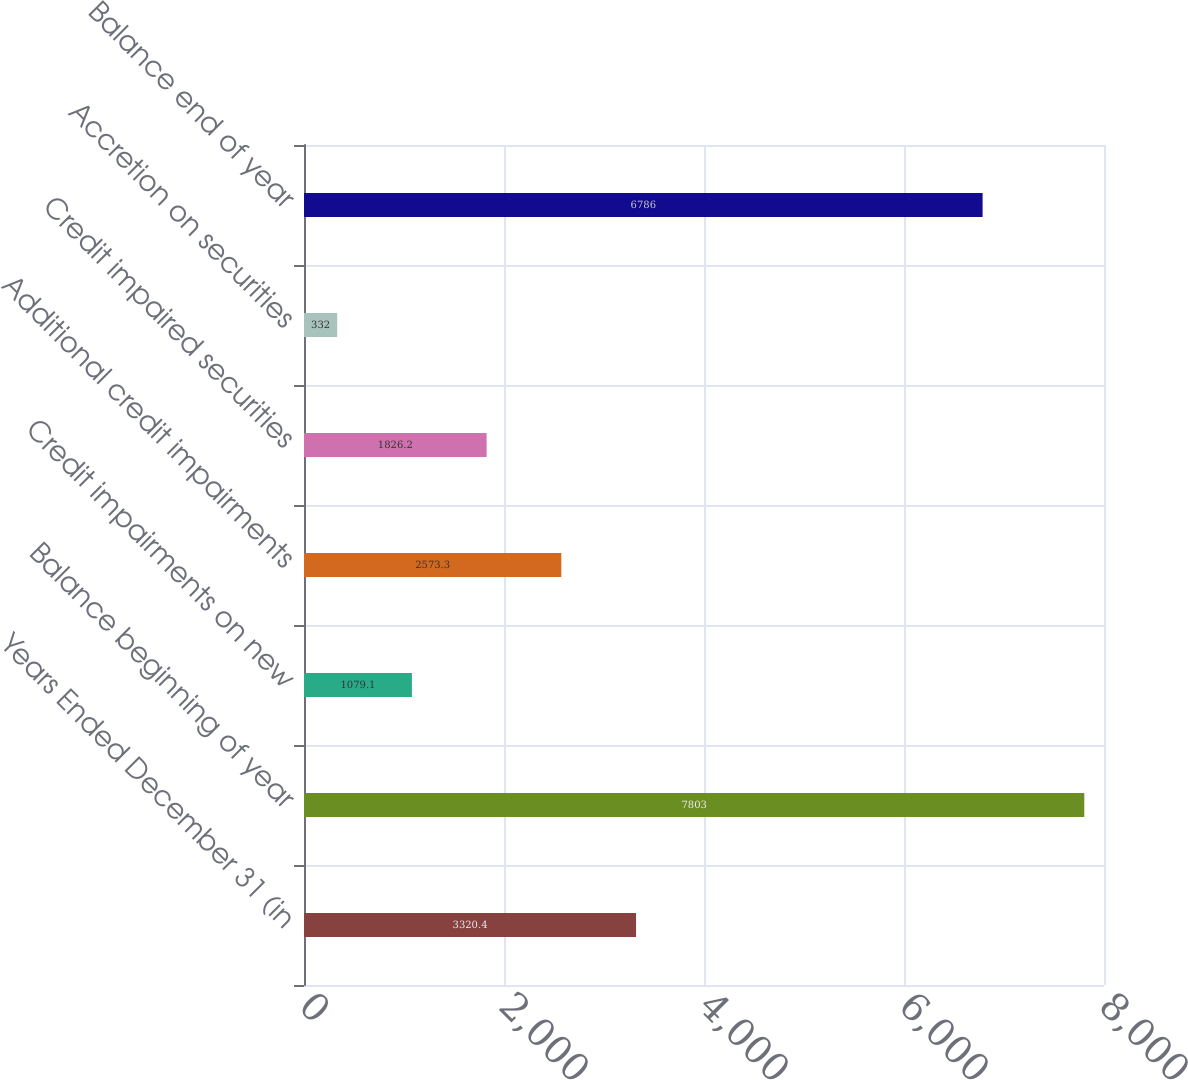Convert chart to OTSL. <chart><loc_0><loc_0><loc_500><loc_500><bar_chart><fcel>Years Ended December 31 (in<fcel>Balance beginning of year<fcel>Credit impairments on new<fcel>Additional credit impairments<fcel>Credit impaired securities<fcel>Accretion on securities<fcel>Balance end of year<nl><fcel>3320.4<fcel>7803<fcel>1079.1<fcel>2573.3<fcel>1826.2<fcel>332<fcel>6786<nl></chart> 